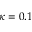<formula> <loc_0><loc_0><loc_500><loc_500>\kappa = 0 . 1</formula> 